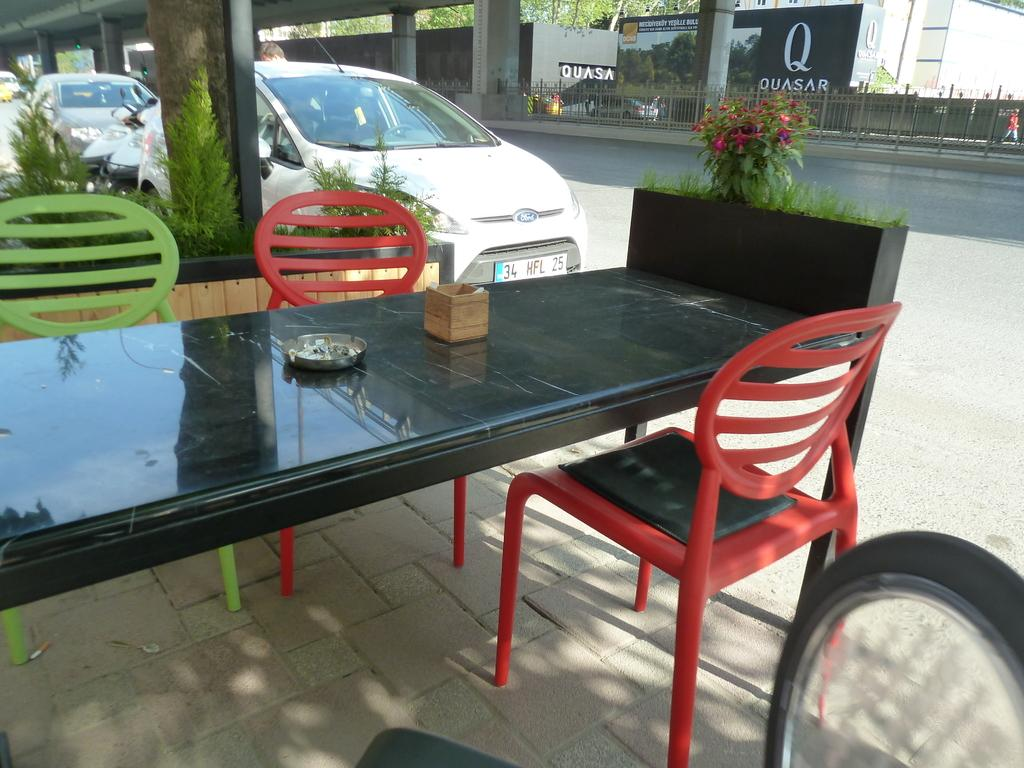What color is the table in the image? The table in the image is black. What is located on either side of the table? There are chairs on either side of the table. What can be seen in the background of the image? Cars and trees are visible in the background of the image. Are there any mittens visible in the image? No, there are no mittens present in the image. Can you tell me how many people are swimming in the image? There is no swimming or water activity depicted in the image. 